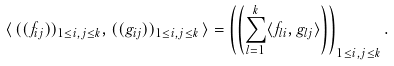<formula> <loc_0><loc_0><loc_500><loc_500>\langle \, ( ( f _ { i j } ) ) _ { 1 \leq i , j \leq k } , ( ( g _ { i j } ) ) _ { 1 \leq i , j \leq k } \, \rangle = \left ( \left ( \sum _ { l = 1 } ^ { k } \langle f _ { l i } , g _ { l j } \rangle \right ) \right ) _ { 1 \leq i , j \leq k } .</formula> 